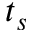<formula> <loc_0><loc_0><loc_500><loc_500>t _ { s }</formula> 